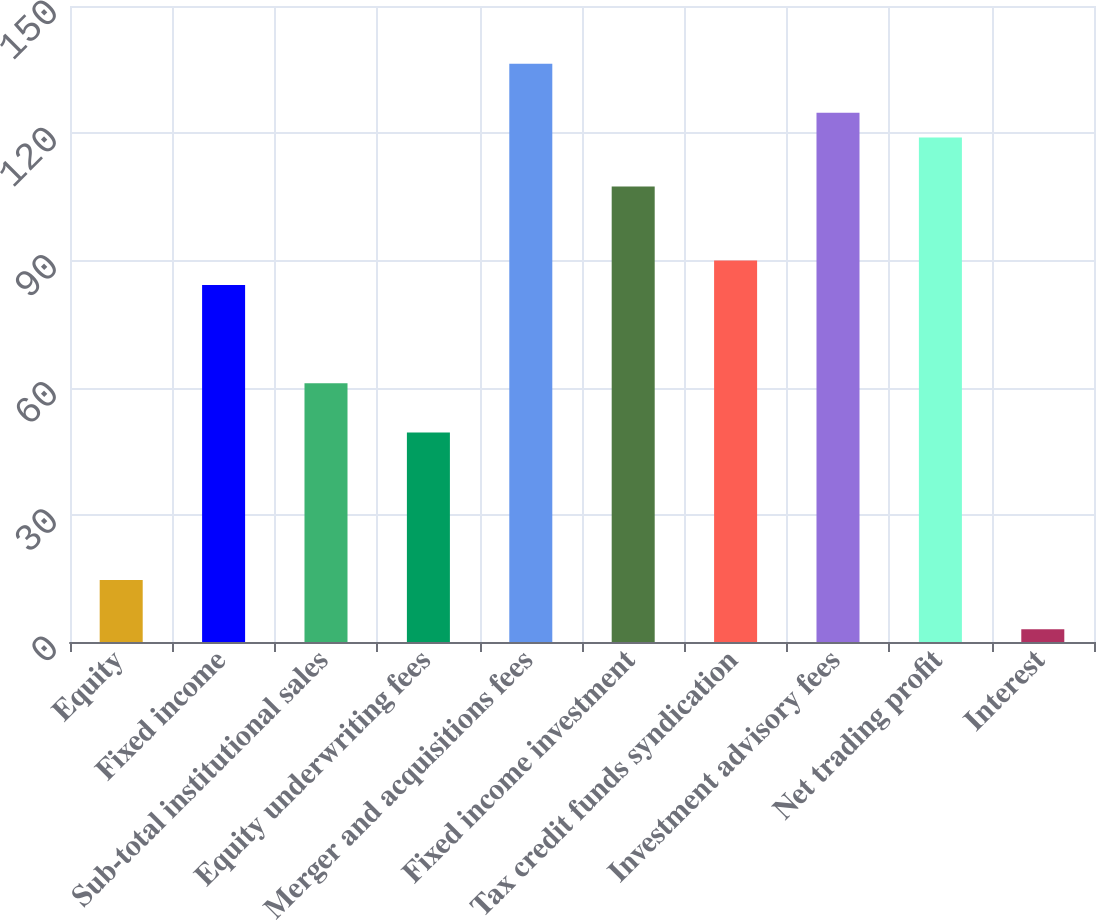Convert chart to OTSL. <chart><loc_0><loc_0><loc_500><loc_500><bar_chart><fcel>Equity<fcel>Fixed income<fcel>Sub-total institutional sales<fcel>Equity underwriting fees<fcel>Merger and acquisitions fees<fcel>Fixed income investment<fcel>Tax credit funds syndication<fcel>Investment advisory fees<fcel>Net trading profit<fcel>Interest<nl><fcel>14.6<fcel>84.2<fcel>61<fcel>49.4<fcel>136.4<fcel>107.4<fcel>90<fcel>124.8<fcel>119<fcel>3<nl></chart> 